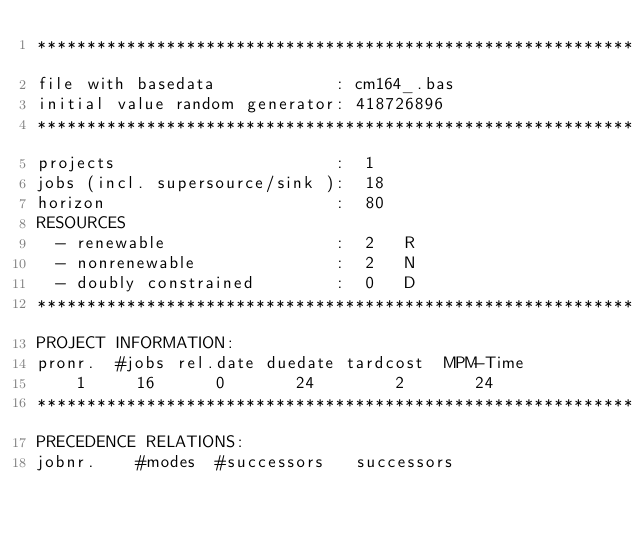<code> <loc_0><loc_0><loc_500><loc_500><_ObjectiveC_>************************************************************************
file with basedata            : cm164_.bas
initial value random generator: 418726896
************************************************************************
projects                      :  1
jobs (incl. supersource/sink ):  18
horizon                       :  80
RESOURCES
  - renewable                 :  2   R
  - nonrenewable              :  2   N
  - doubly constrained        :  0   D
************************************************************************
PROJECT INFORMATION:
pronr.  #jobs rel.date duedate tardcost  MPM-Time
    1     16      0       24        2       24
************************************************************************
PRECEDENCE RELATIONS:
jobnr.    #modes  #successors   successors</code> 